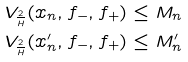<formula> <loc_0><loc_0><loc_500><loc_500>V _ { \frac { 2 } { H } } ( x _ { n } , f _ { - } , f _ { + } ) \leq M _ { n } \\ V _ { \frac { 2 } { H } } ( x _ { n } ^ { \prime } , f _ { - } , f _ { + } ) \leq M _ { n } ^ { \prime }</formula> 